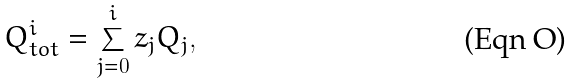Convert formula to latex. <formula><loc_0><loc_0><loc_500><loc_500>Q ^ { i } _ { t o t } = \sum _ { j = 0 } ^ { i } z _ { j } Q _ { j } ,</formula> 